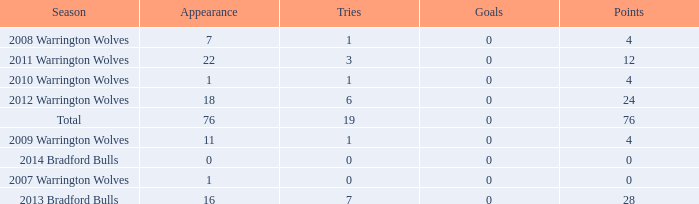How many times is tries 0 and appearance less than 0? 0.0. 